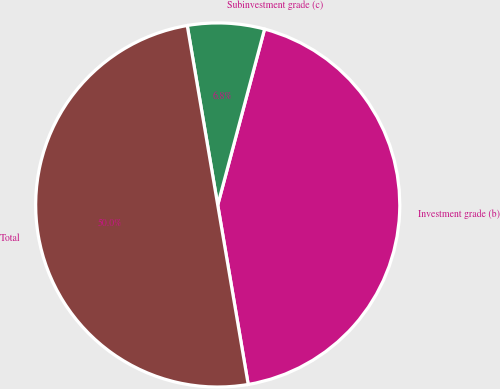<chart> <loc_0><loc_0><loc_500><loc_500><pie_chart><fcel>Investment grade (b)<fcel>Subinvestment grade (c)<fcel>Total<nl><fcel>43.18%<fcel>6.82%<fcel>50.0%<nl></chart> 